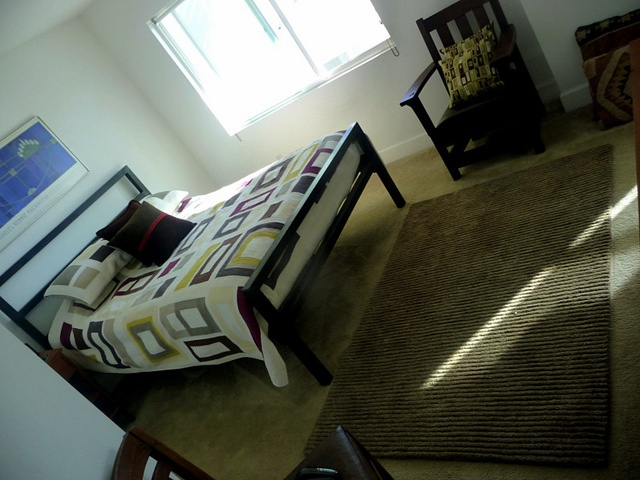Describe the objects in this image and their specific colors. I can see bed in gray, black, and darkgray tones, chair in gray, black, and darkgreen tones, and chair in gray and black tones in this image. 